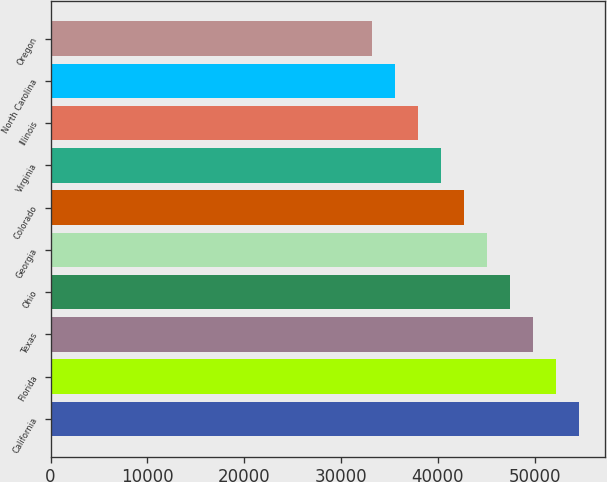<chart> <loc_0><loc_0><loc_500><loc_500><bar_chart><fcel>California<fcel>Florida<fcel>Texas<fcel>Ohio<fcel>Georgia<fcel>Colorado<fcel>Virginia<fcel>Illinois<fcel>North Carolina<fcel>Oregon<nl><fcel>54595.1<fcel>52222.4<fcel>49849.7<fcel>47477<fcel>45104.3<fcel>42731.6<fcel>40358.9<fcel>37986.2<fcel>35613.5<fcel>33240.8<nl></chart> 